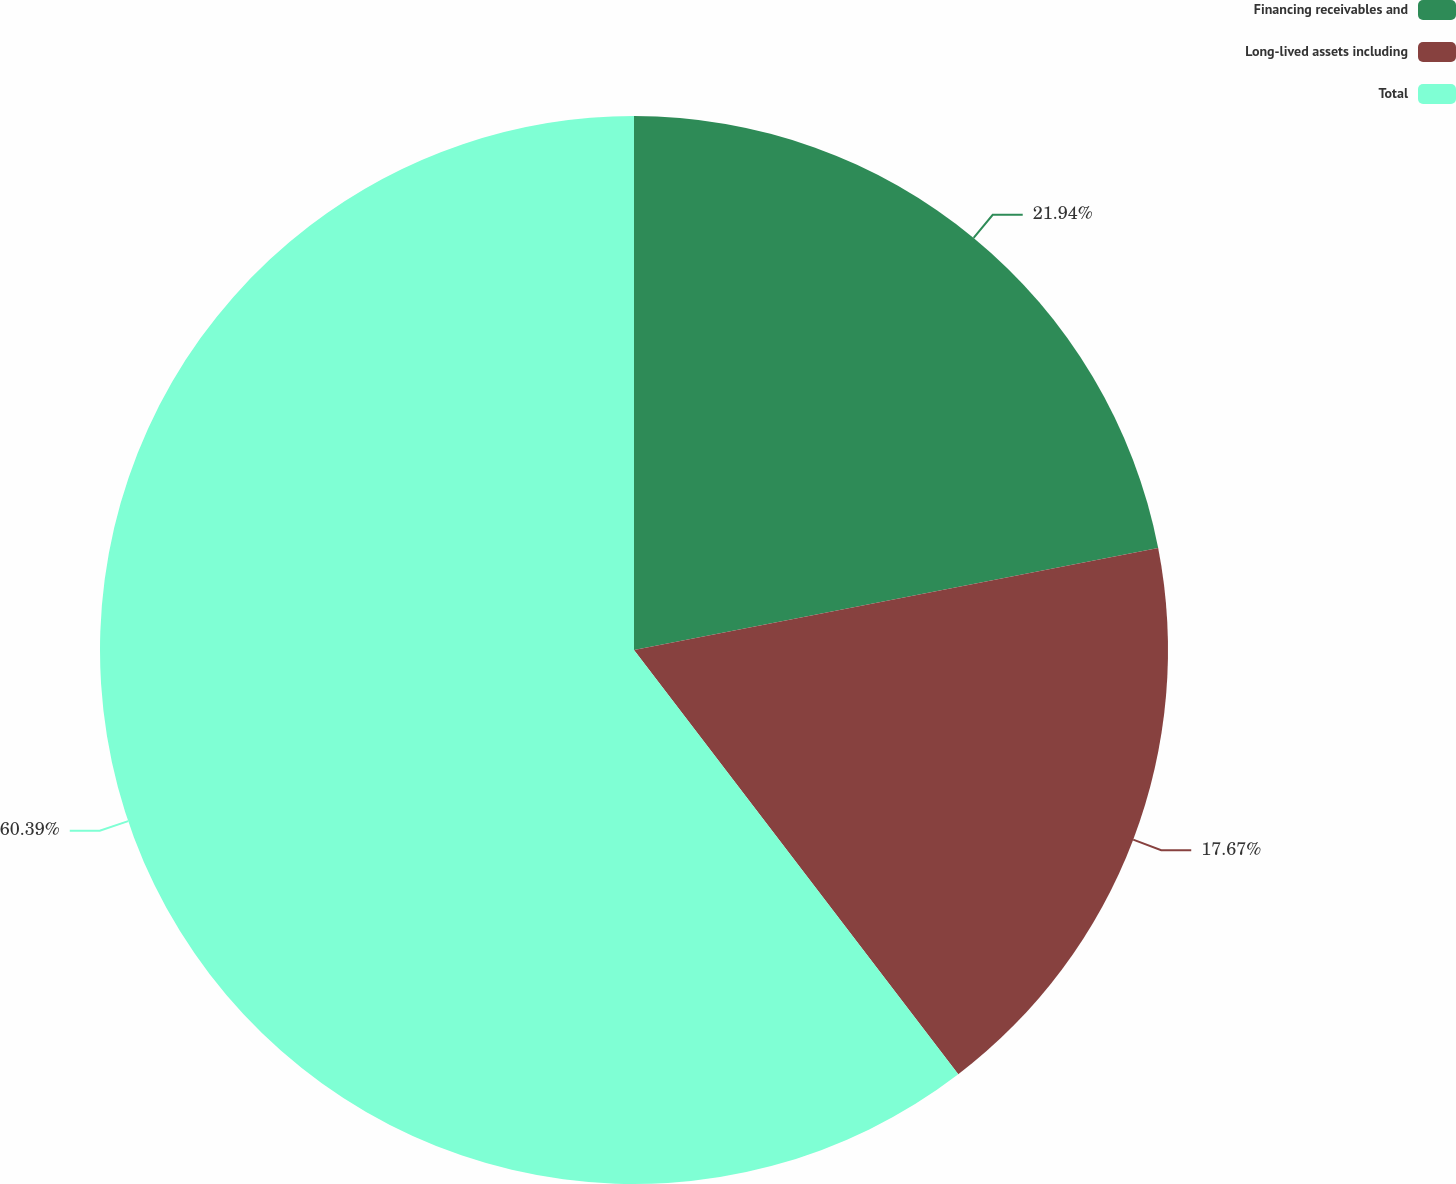<chart> <loc_0><loc_0><loc_500><loc_500><pie_chart><fcel>Financing receivables and<fcel>Long-lived assets including<fcel>Total<nl><fcel>21.94%<fcel>17.67%<fcel>60.38%<nl></chart> 